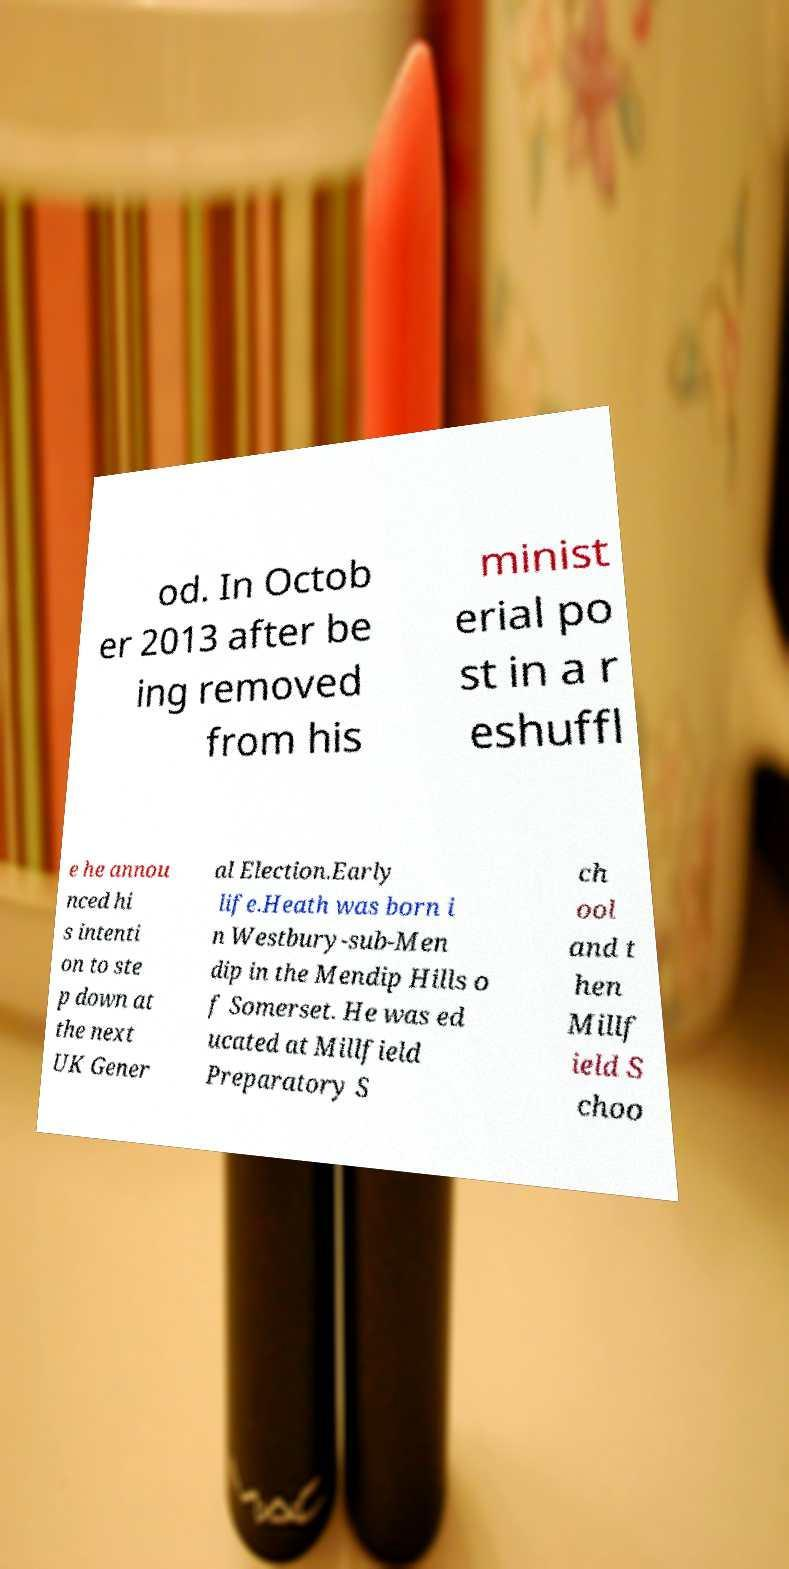Can you read and provide the text displayed in the image?This photo seems to have some interesting text. Can you extract and type it out for me? od. In Octob er 2013 after be ing removed from his minist erial po st in a r eshuffl e he annou nced hi s intenti on to ste p down at the next UK Gener al Election.Early life.Heath was born i n Westbury-sub-Men dip in the Mendip Hills o f Somerset. He was ed ucated at Millfield Preparatory S ch ool and t hen Millf ield S choo 